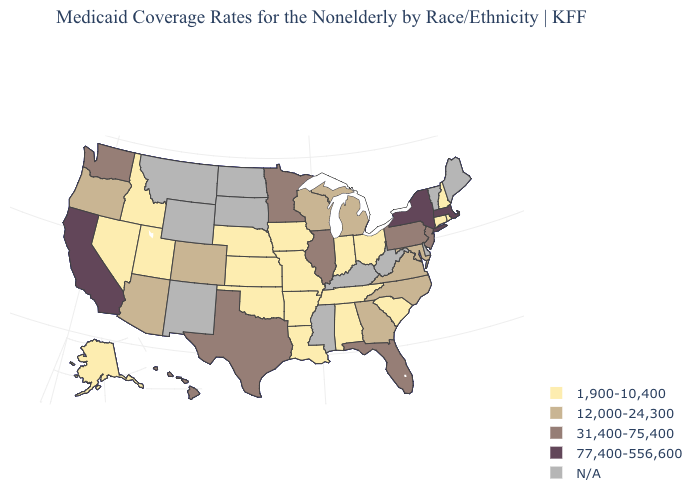Which states have the lowest value in the USA?
Give a very brief answer. Alabama, Alaska, Arkansas, Connecticut, Idaho, Indiana, Iowa, Kansas, Louisiana, Missouri, Nebraska, Nevada, New Hampshire, Ohio, Oklahoma, Rhode Island, South Carolina, Tennessee, Utah. Is the legend a continuous bar?
Short answer required. No. What is the lowest value in states that border Nevada?
Give a very brief answer. 1,900-10,400. Name the states that have a value in the range 31,400-75,400?
Quick response, please. Florida, Hawaii, Illinois, Minnesota, New Jersey, Pennsylvania, Texas, Washington. How many symbols are there in the legend?
Short answer required. 5. Name the states that have a value in the range N/A?
Keep it brief. Delaware, Kentucky, Maine, Mississippi, Montana, New Mexico, North Dakota, South Dakota, Vermont, West Virginia, Wyoming. What is the lowest value in the USA?
Keep it brief. 1,900-10,400. What is the value of Oregon?
Be succinct. 12,000-24,300. What is the highest value in states that border North Carolina?
Answer briefly. 12,000-24,300. Among the states that border Florida , does Alabama have the highest value?
Keep it brief. No. Does the first symbol in the legend represent the smallest category?
Quick response, please. Yes. Which states have the lowest value in the USA?
Be succinct. Alabama, Alaska, Arkansas, Connecticut, Idaho, Indiana, Iowa, Kansas, Louisiana, Missouri, Nebraska, Nevada, New Hampshire, Ohio, Oklahoma, Rhode Island, South Carolina, Tennessee, Utah. Does Florida have the lowest value in the South?
Answer briefly. No. What is the value of Tennessee?
Write a very short answer. 1,900-10,400. 